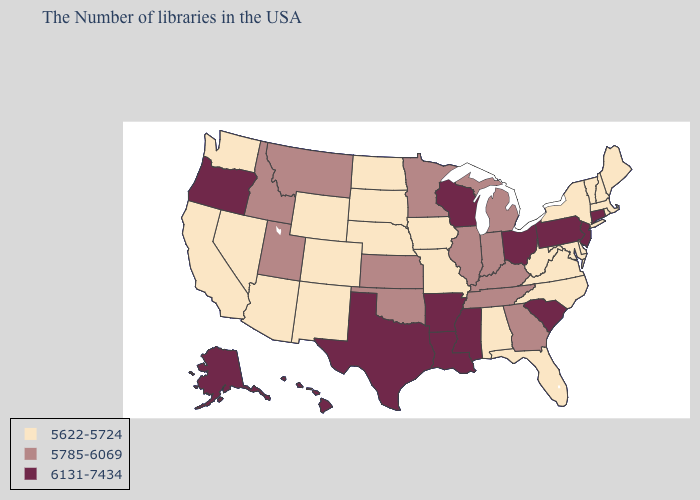Is the legend a continuous bar?
Short answer required. No. Name the states that have a value in the range 5785-6069?
Write a very short answer. Georgia, Michigan, Kentucky, Indiana, Tennessee, Illinois, Minnesota, Kansas, Oklahoma, Utah, Montana, Idaho. Which states have the lowest value in the South?
Concise answer only. Delaware, Maryland, Virginia, North Carolina, West Virginia, Florida, Alabama. Name the states that have a value in the range 5622-5724?
Keep it brief. Maine, Massachusetts, Rhode Island, New Hampshire, Vermont, New York, Delaware, Maryland, Virginia, North Carolina, West Virginia, Florida, Alabama, Missouri, Iowa, Nebraska, South Dakota, North Dakota, Wyoming, Colorado, New Mexico, Arizona, Nevada, California, Washington. Name the states that have a value in the range 6131-7434?
Keep it brief. Connecticut, New Jersey, Pennsylvania, South Carolina, Ohio, Wisconsin, Mississippi, Louisiana, Arkansas, Texas, Oregon, Alaska, Hawaii. Name the states that have a value in the range 5785-6069?
Be succinct. Georgia, Michigan, Kentucky, Indiana, Tennessee, Illinois, Minnesota, Kansas, Oklahoma, Utah, Montana, Idaho. What is the value of Texas?
Answer briefly. 6131-7434. What is the value of Connecticut?
Write a very short answer. 6131-7434. Does Delaware have the same value as Colorado?
Concise answer only. Yes. Which states hav the highest value in the South?
Give a very brief answer. South Carolina, Mississippi, Louisiana, Arkansas, Texas. What is the highest value in states that border Iowa?
Concise answer only. 6131-7434. Name the states that have a value in the range 6131-7434?
Quick response, please. Connecticut, New Jersey, Pennsylvania, South Carolina, Ohio, Wisconsin, Mississippi, Louisiana, Arkansas, Texas, Oregon, Alaska, Hawaii. Which states have the highest value in the USA?
Short answer required. Connecticut, New Jersey, Pennsylvania, South Carolina, Ohio, Wisconsin, Mississippi, Louisiana, Arkansas, Texas, Oregon, Alaska, Hawaii. Name the states that have a value in the range 5622-5724?
Quick response, please. Maine, Massachusetts, Rhode Island, New Hampshire, Vermont, New York, Delaware, Maryland, Virginia, North Carolina, West Virginia, Florida, Alabama, Missouri, Iowa, Nebraska, South Dakota, North Dakota, Wyoming, Colorado, New Mexico, Arizona, Nevada, California, Washington. Name the states that have a value in the range 6131-7434?
Write a very short answer. Connecticut, New Jersey, Pennsylvania, South Carolina, Ohio, Wisconsin, Mississippi, Louisiana, Arkansas, Texas, Oregon, Alaska, Hawaii. 